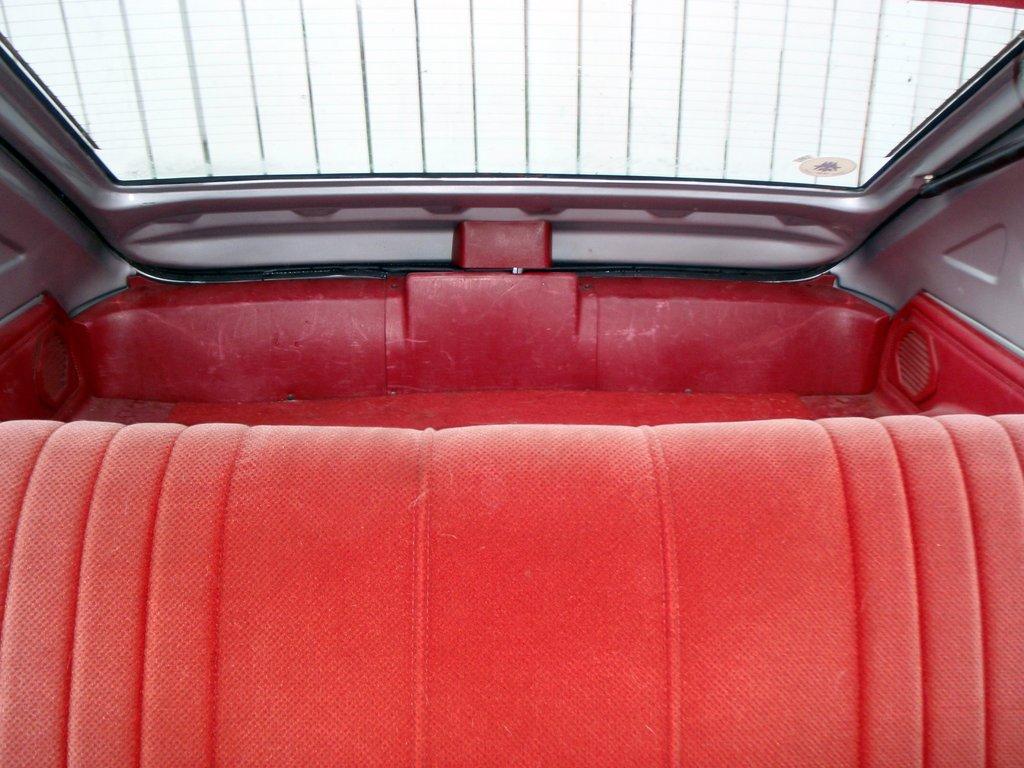Describe this image in one or two sentences. This picture describes about inside view of a car, and we can see a seat. 